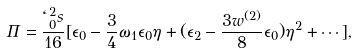Convert formula to latex. <formula><loc_0><loc_0><loc_500><loc_500>\Pi = \frac { \ell _ { 0 } ^ { 2 } s } { 1 6 } [ \epsilon _ { 0 } - \frac { 3 } { 4 } \omega _ { 1 } \epsilon _ { 0 } \eta + ( \epsilon _ { 2 } - \frac { 3 w ^ { ( 2 ) } } { 8 } \epsilon _ { 0 } ) \eta ^ { 2 } + \cdots ] ,</formula> 